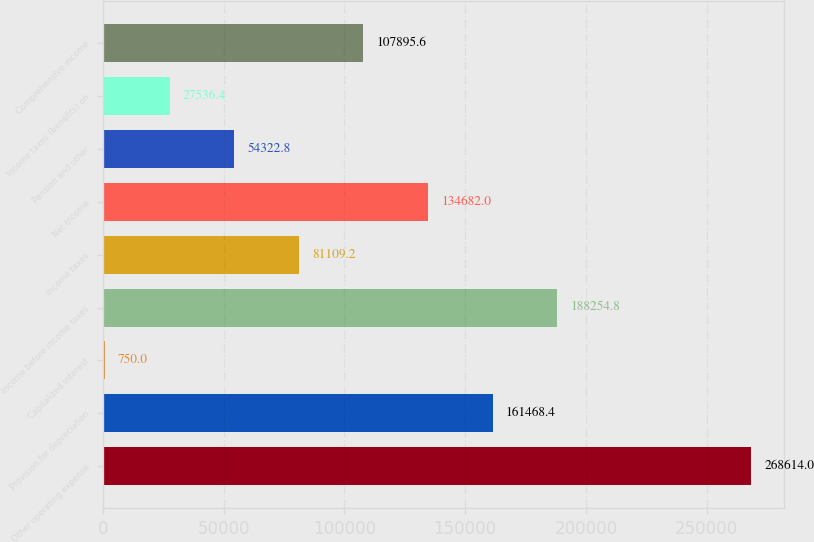Convert chart to OTSL. <chart><loc_0><loc_0><loc_500><loc_500><bar_chart><fcel>Other operating expense<fcel>Provision for depreciation<fcel>Capitalized interest<fcel>Income before income taxes<fcel>Income taxes<fcel>Net Income<fcel>Pension and other<fcel>Income taxes (benefits) on<fcel>Comprehensive income<nl><fcel>268614<fcel>161468<fcel>750<fcel>188255<fcel>81109.2<fcel>134682<fcel>54322.8<fcel>27536.4<fcel>107896<nl></chart> 